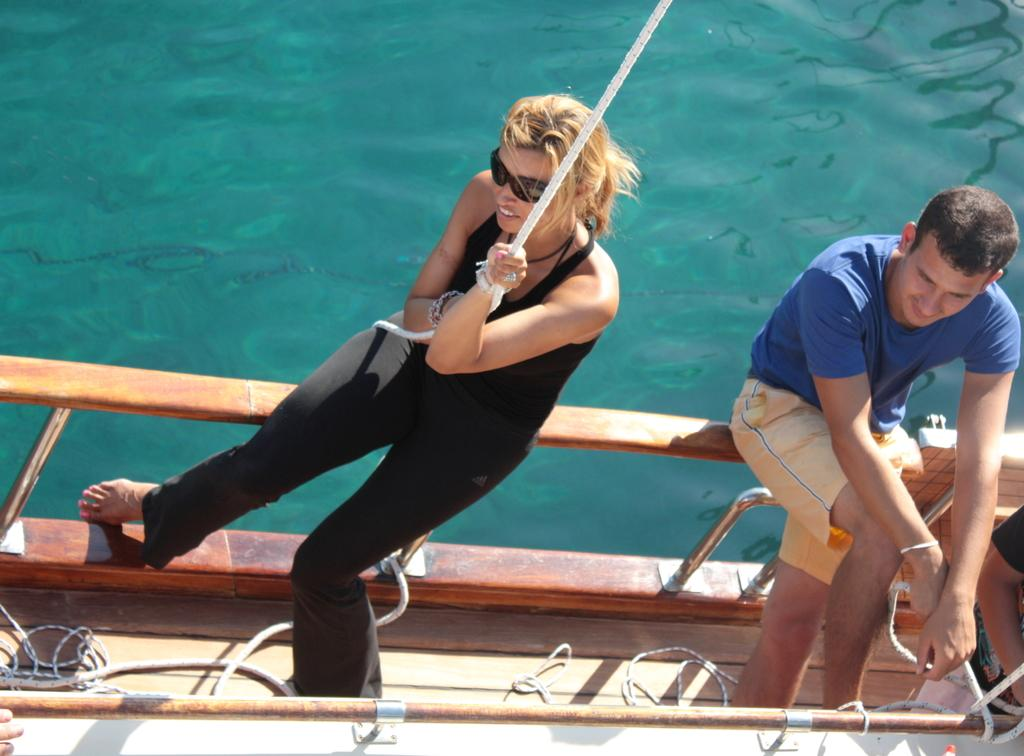What is the woman in the image wearing? The woman is wearing a black dress. What is the woman doing in the image? The woman is sitting on a ship and holding a rope. What is the man in the image wearing? The man is wearing a blue t-shirt. What is the man doing in the image? The man is sitting on the ship. What can be seen in the background of the image? There is a sea visible in the image. What type of juice is the woman drinking in the image? There is no juice present in the image. 